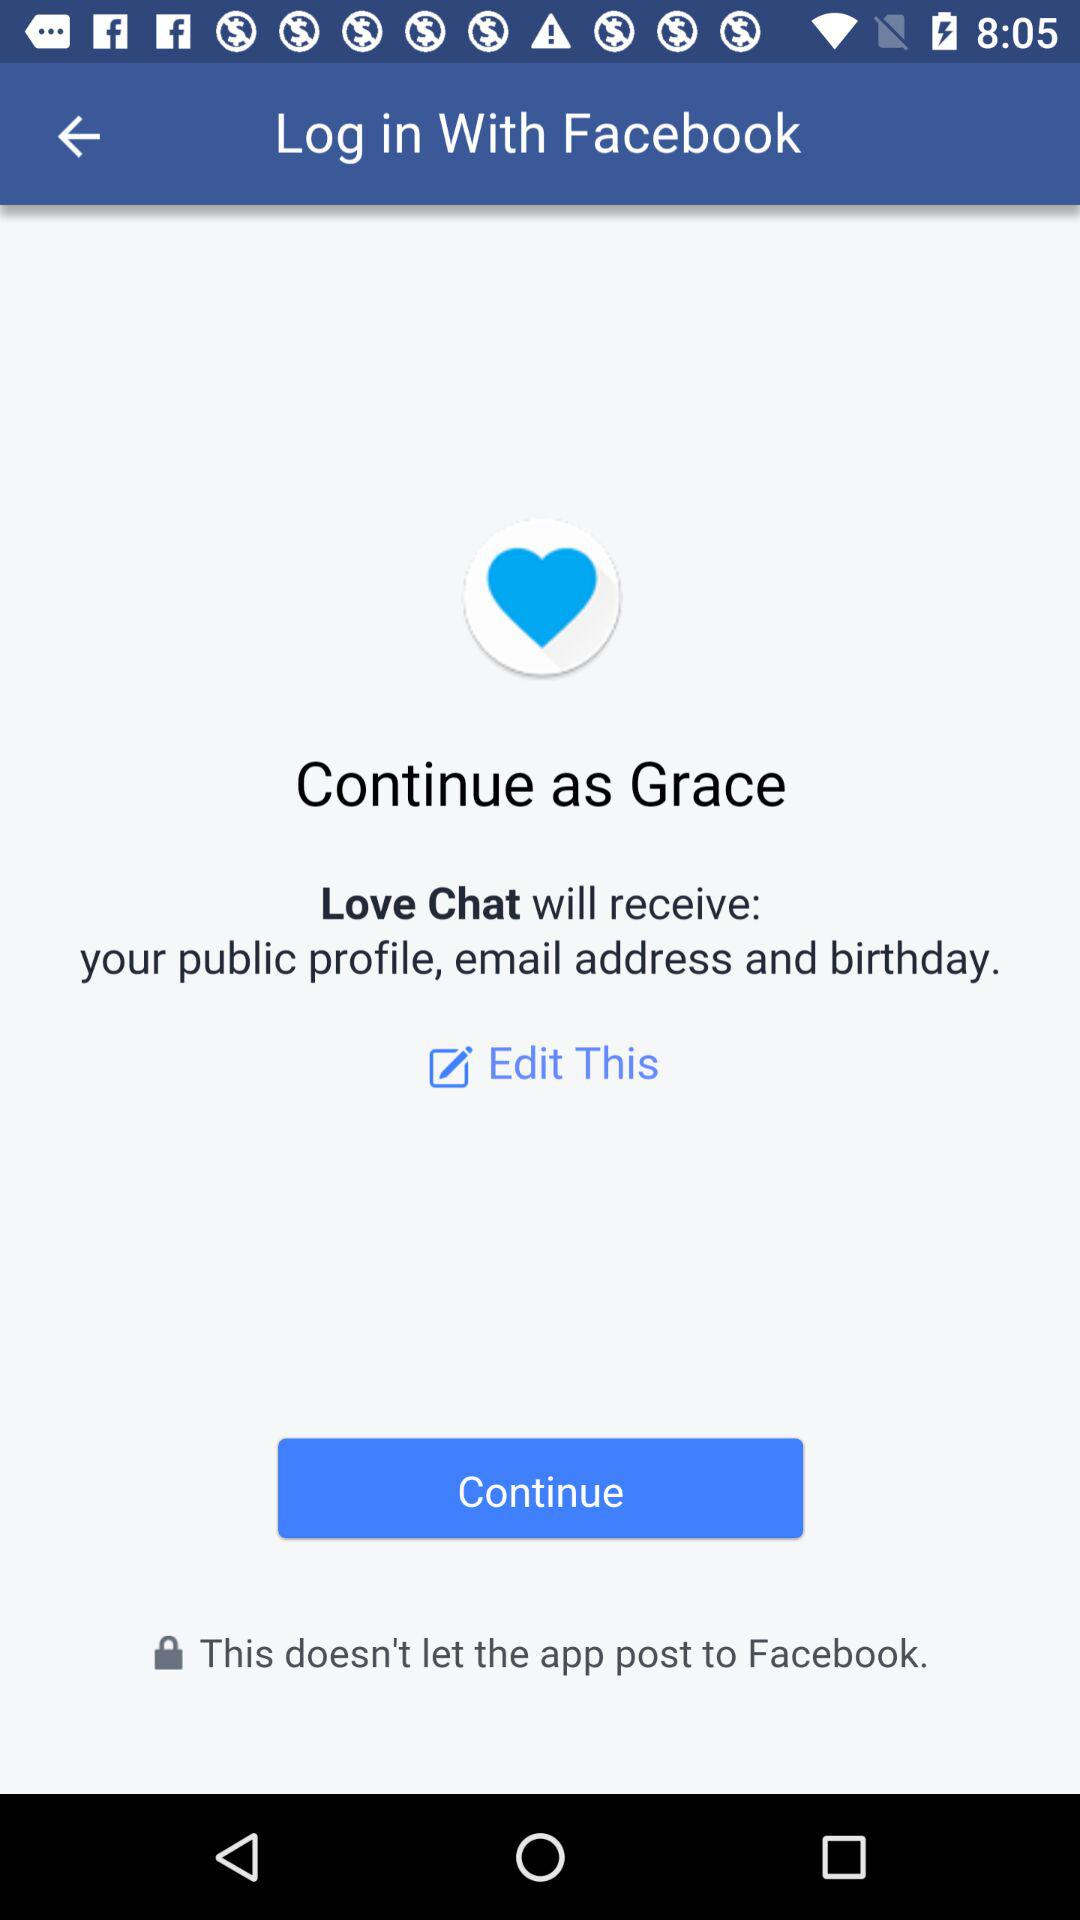What application is asking for permission? The application "Love Chat" is asking for permission. 